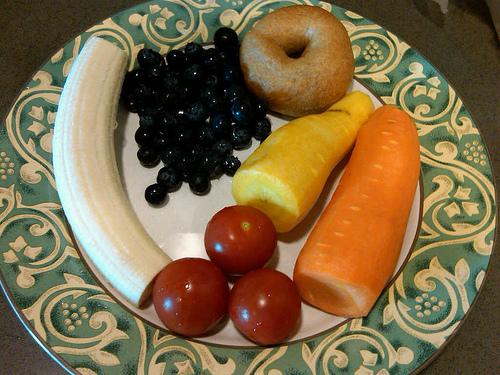How many items have been sliced?
Give a very brief answer. 0. How many vegetables are on the plate?
Write a very short answer. 2. What is white?
Write a very short answer. Banana. 